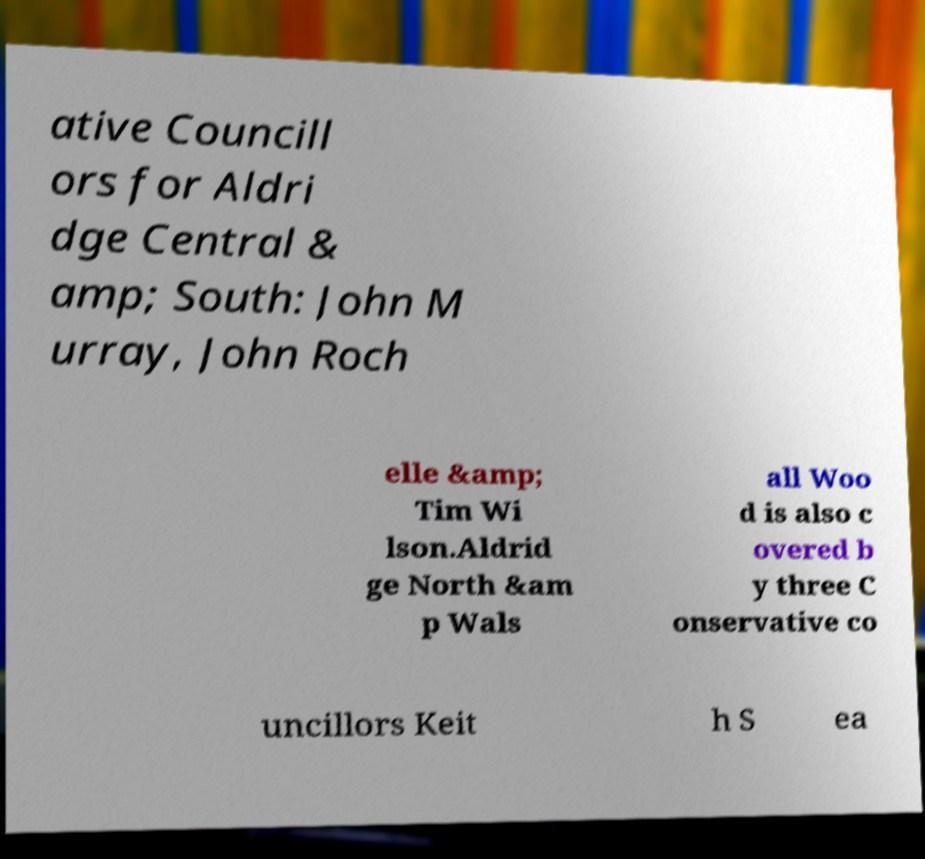Please identify and transcribe the text found in this image. ative Councill ors for Aldri dge Central & amp; South: John M urray, John Roch elle &amp; Tim Wi lson.Aldrid ge North &am p Wals all Woo d is also c overed b y three C onservative co uncillors Keit h S ea 